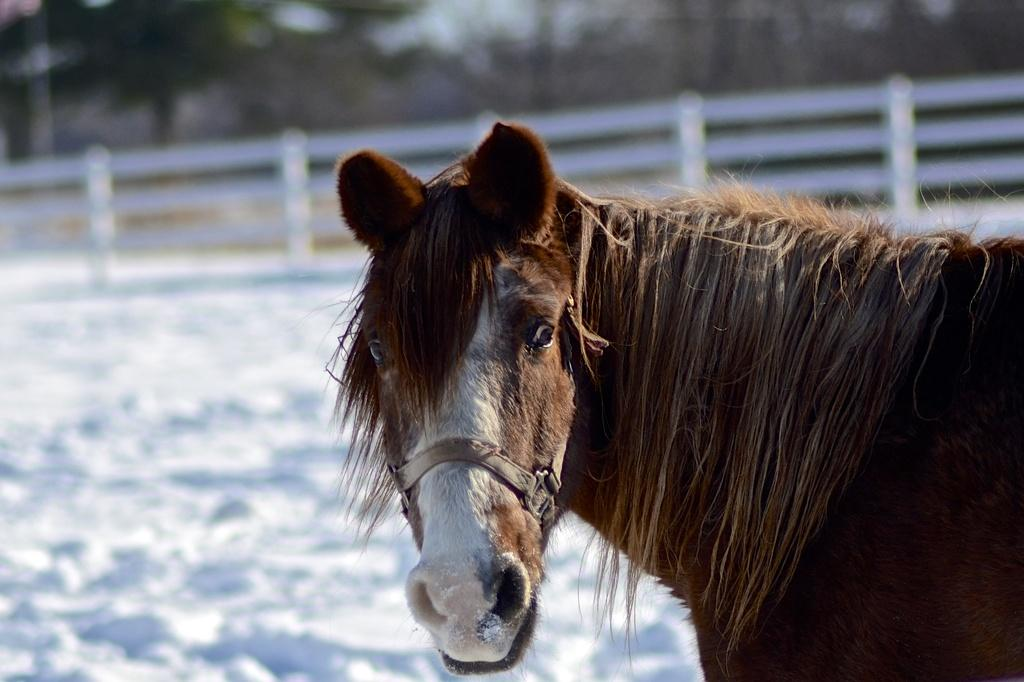What type of animal is in the image? There is a brown horse in the image. What is the horse standing on? The horse is standing on a snow surface. What can be seen in the background of the image? There is white color fencing and trees in the background of the image. What part of the natural environment is visible in the image? The sky is visible in the background of the image. How many lamps are hanging from the horse's neck in the image? There are no lamps present in the image; it features a brown horse standing on a snow surface with white color fencing and trees in the background. 